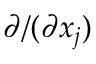Convert formula to latex. <formula><loc_0><loc_0><loc_500><loc_500>\partial / ( \partial x _ { j } )</formula> 